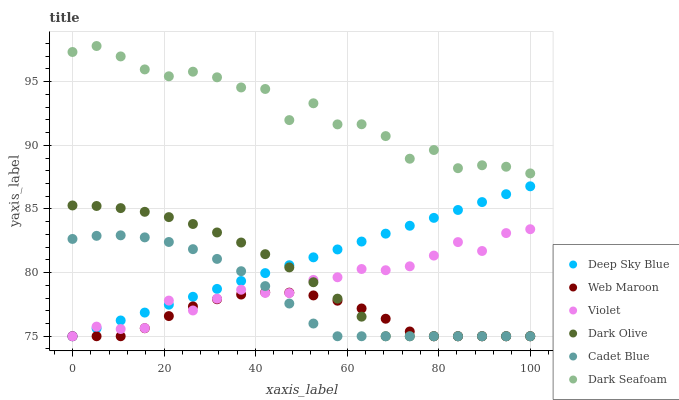Does Web Maroon have the minimum area under the curve?
Answer yes or no. Yes. Does Dark Seafoam have the maximum area under the curve?
Answer yes or no. Yes. Does Dark Olive have the minimum area under the curve?
Answer yes or no. No. Does Dark Olive have the maximum area under the curve?
Answer yes or no. No. Is Deep Sky Blue the smoothest?
Answer yes or no. Yes. Is Dark Seafoam the roughest?
Answer yes or no. Yes. Is Dark Olive the smoothest?
Answer yes or no. No. Is Dark Olive the roughest?
Answer yes or no. No. Does Cadet Blue have the lowest value?
Answer yes or no. Yes. Does Dark Seafoam have the lowest value?
Answer yes or no. No. Does Dark Seafoam have the highest value?
Answer yes or no. Yes. Does Dark Olive have the highest value?
Answer yes or no. No. Is Cadet Blue less than Dark Seafoam?
Answer yes or no. Yes. Is Dark Seafoam greater than Dark Olive?
Answer yes or no. Yes. Does Cadet Blue intersect Deep Sky Blue?
Answer yes or no. Yes. Is Cadet Blue less than Deep Sky Blue?
Answer yes or no. No. Is Cadet Blue greater than Deep Sky Blue?
Answer yes or no. No. Does Cadet Blue intersect Dark Seafoam?
Answer yes or no. No. 